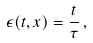<formula> <loc_0><loc_0><loc_500><loc_500>\epsilon ( t , x ) = \frac { t } { \tau } \, ,</formula> 